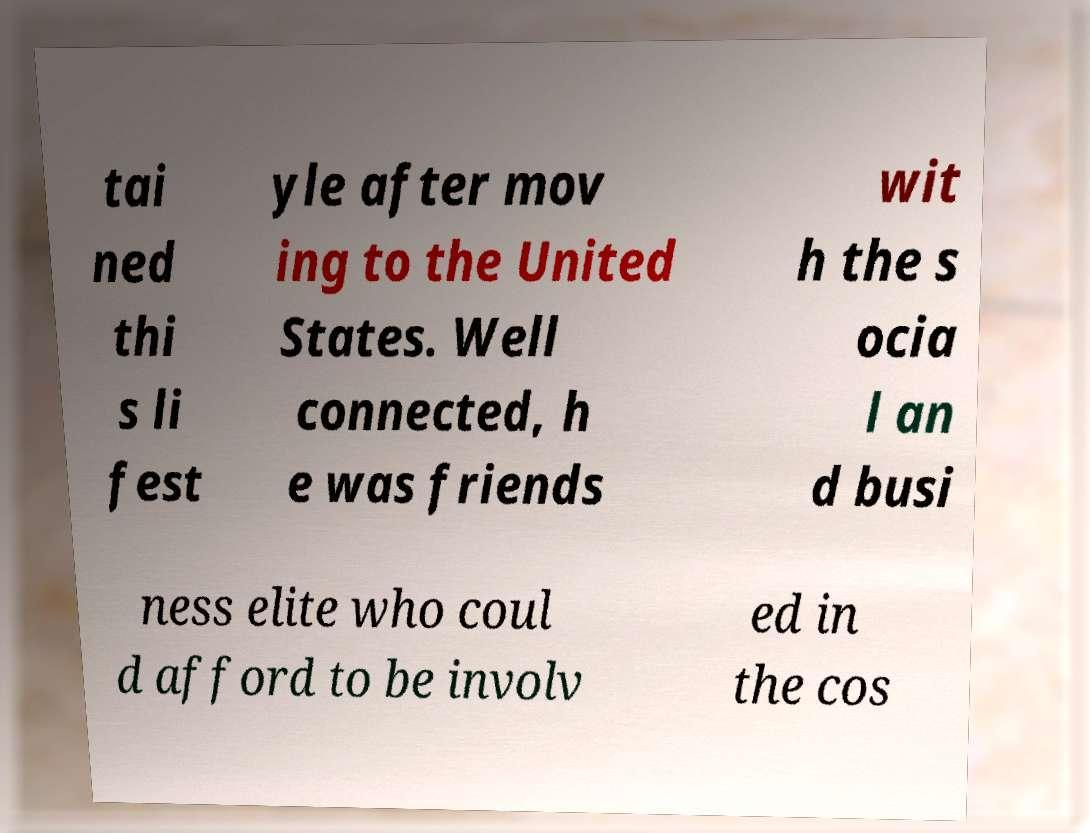Please read and relay the text visible in this image. What does it say? tai ned thi s li fest yle after mov ing to the United States. Well connected, h e was friends wit h the s ocia l an d busi ness elite who coul d afford to be involv ed in the cos 